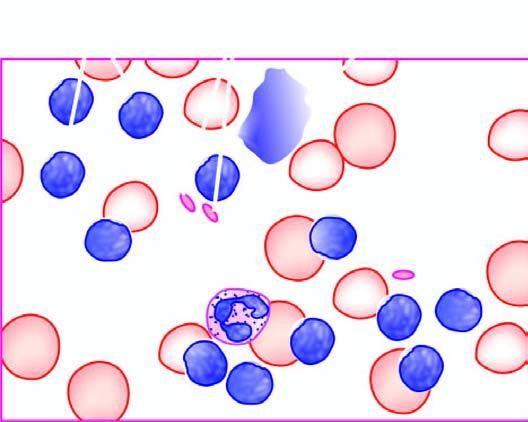s epithelial degenerate forms appearing as bare smudged nuclei?
Answer the question using a single word or phrase. No 